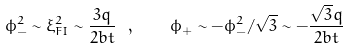Convert formula to latex. <formula><loc_0><loc_0><loc_500><loc_500>\phi _ { - } ^ { 2 } \sim \xi _ { F I } ^ { 2 } \sim \frac { 3 q } { 2 b t } \ , \quad \phi _ { + } \sim - \phi _ { - } ^ { 2 } / \sqrt { 3 } \sim - \frac { \sqrt { 3 } q } { 2 b t }</formula> 